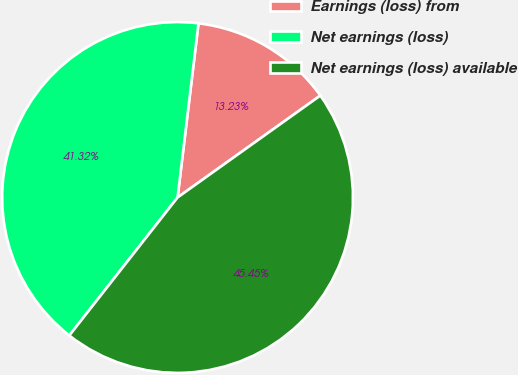Convert chart. <chart><loc_0><loc_0><loc_500><loc_500><pie_chart><fcel>Earnings (loss) from<fcel>Net earnings (loss)<fcel>Net earnings (loss) available<nl><fcel>13.23%<fcel>41.32%<fcel>45.45%<nl></chart> 